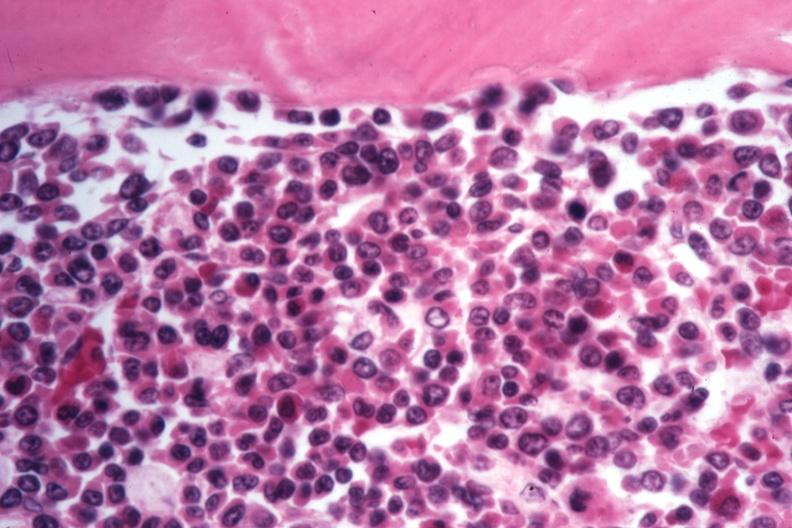s hematologic present?
Answer the question using a single word or phrase. Yes 